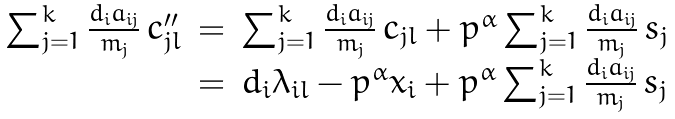<formula> <loc_0><loc_0><loc_500><loc_500>\begin{array} { c c l } \sum _ { j = 1 } ^ { k } \frac { d _ { i } a _ { i j } } { m _ { j } } \, c _ { j l } ^ { \prime \prime } & = & \sum _ { j = 1 } ^ { k } \frac { d _ { i } a _ { i j } } { m _ { j } } \, c _ { j l } + p ^ { \alpha } \sum _ { j = 1 } ^ { k } \frac { d _ { i } a _ { i j } } { m _ { j } } \, s _ { j } \\ & = & d _ { i } \lambda _ { i l } - p ^ { \alpha } x _ { i } + p ^ { \alpha } \sum _ { j = 1 } ^ { k } \frac { d _ { i } a _ { i j } } { m _ { j } } \, s _ { j } \end{array}</formula> 